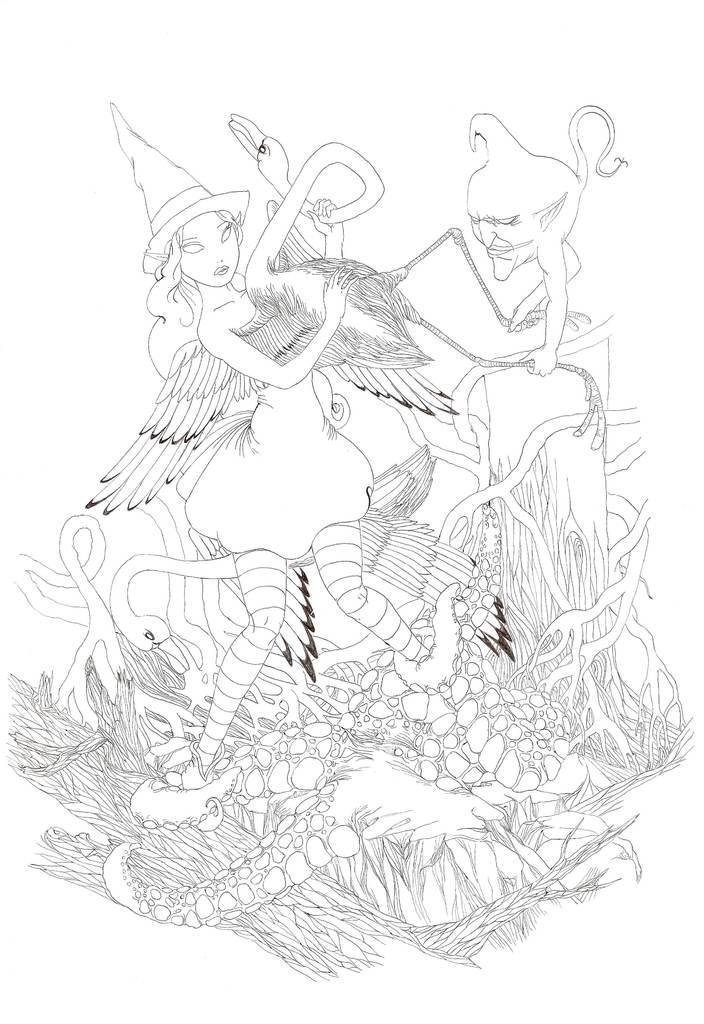How would you summarize this image in a sentence or two? In this image we can see the drawing of a woman holding the duck in her hand. Here we can see another duck. Here we can see the trunk and roots of the tree. Here we can see the face of the person holding the legs of the duck. 